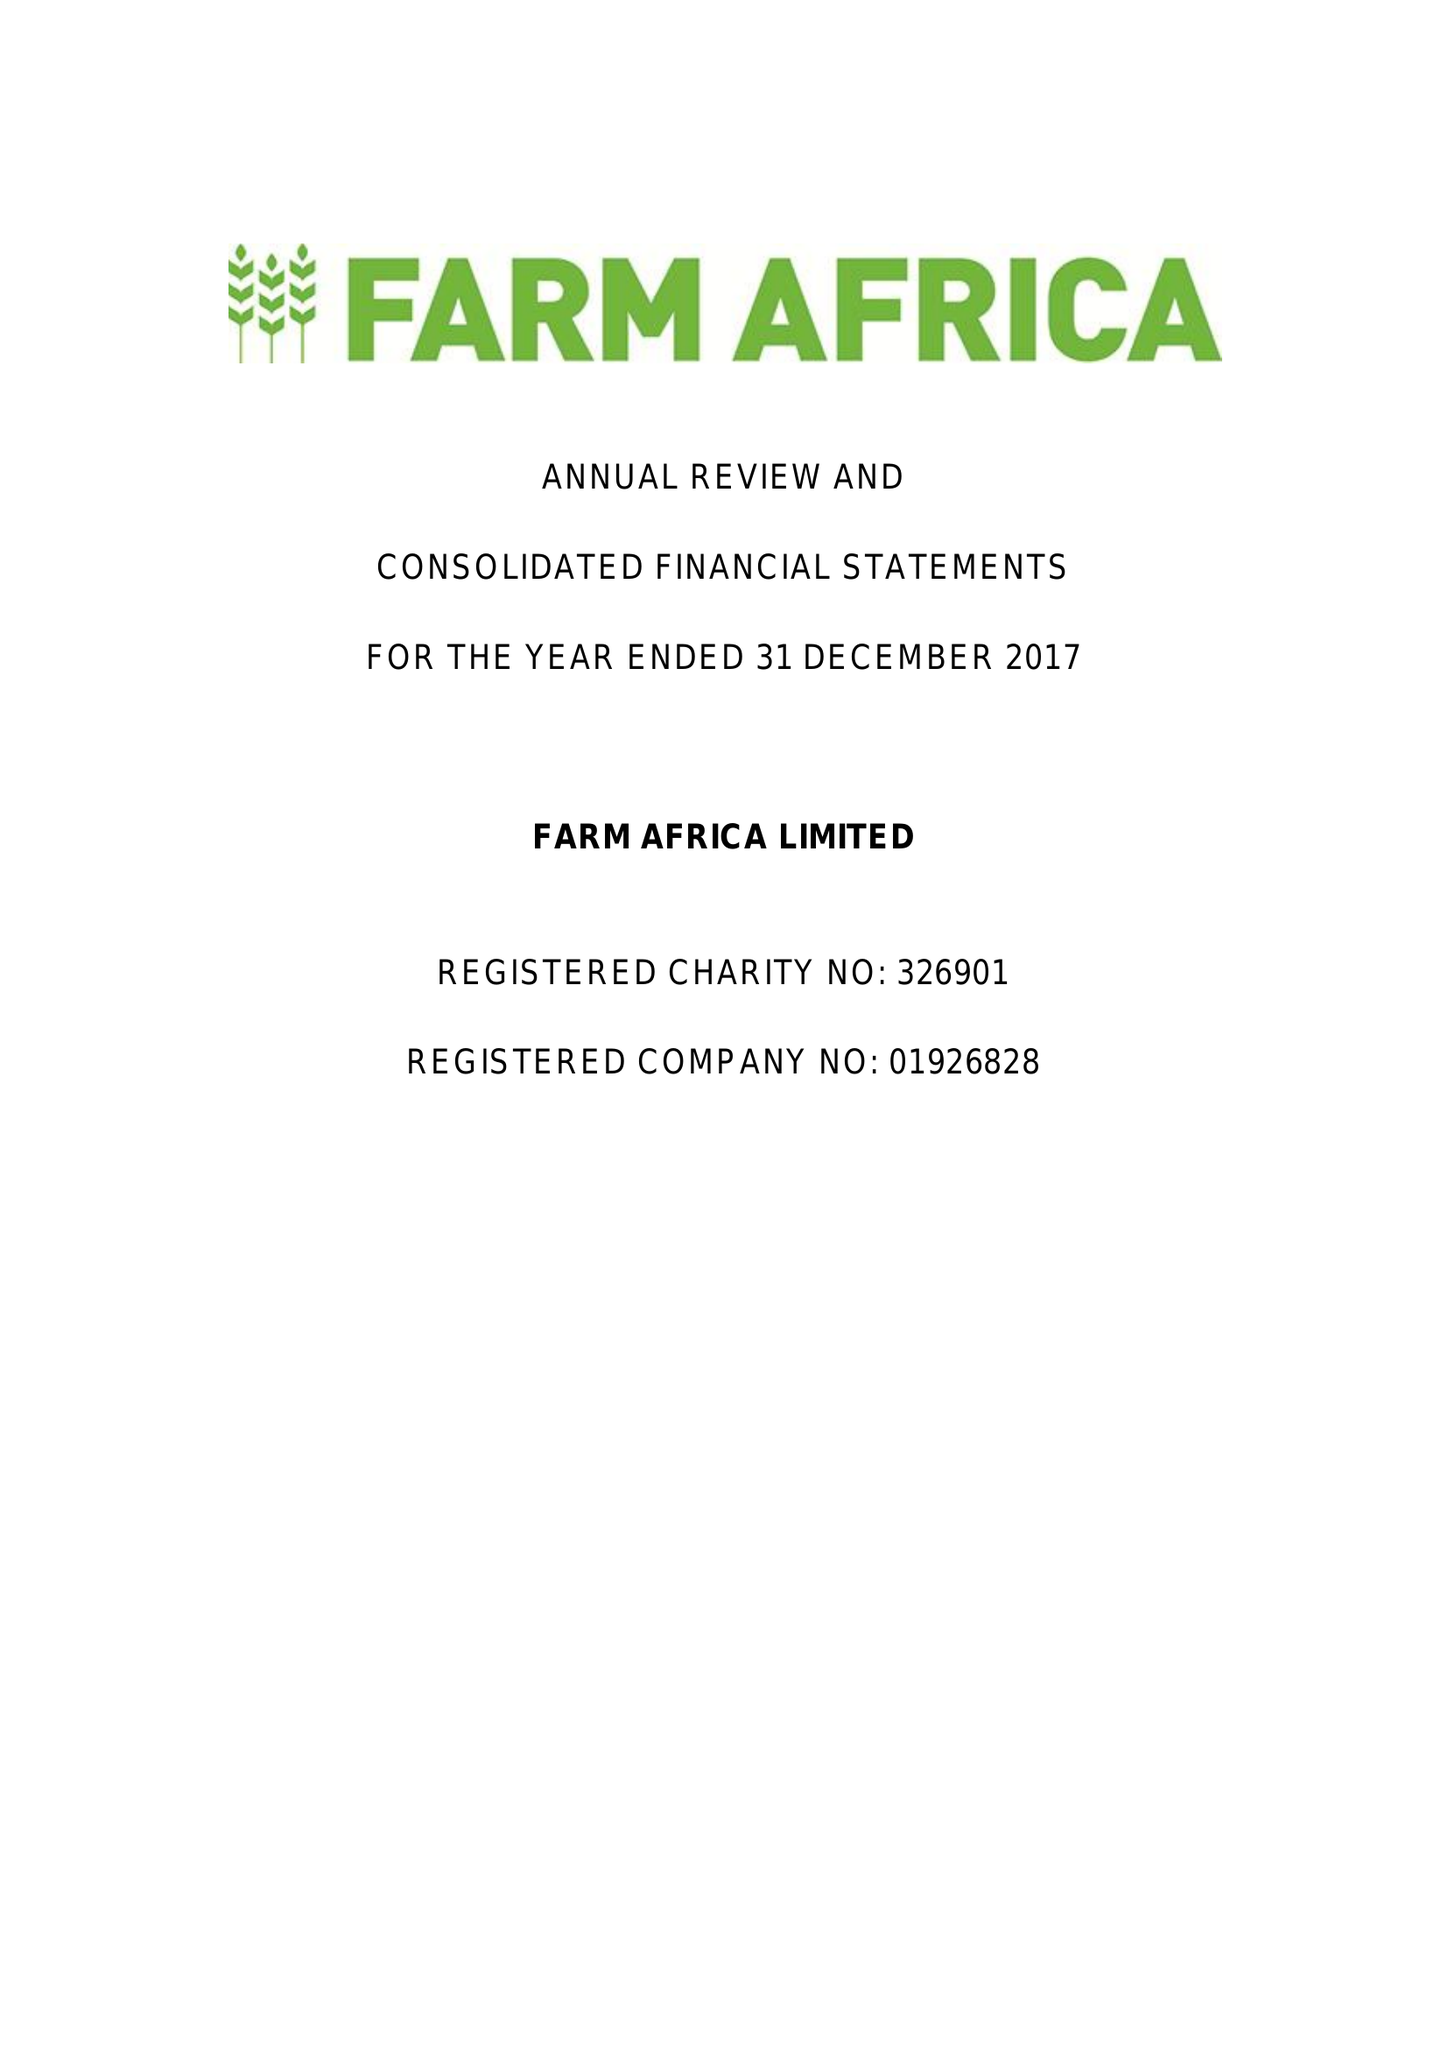What is the value for the spending_annually_in_british_pounds?
Answer the question using a single word or phrase. 16446000.00 